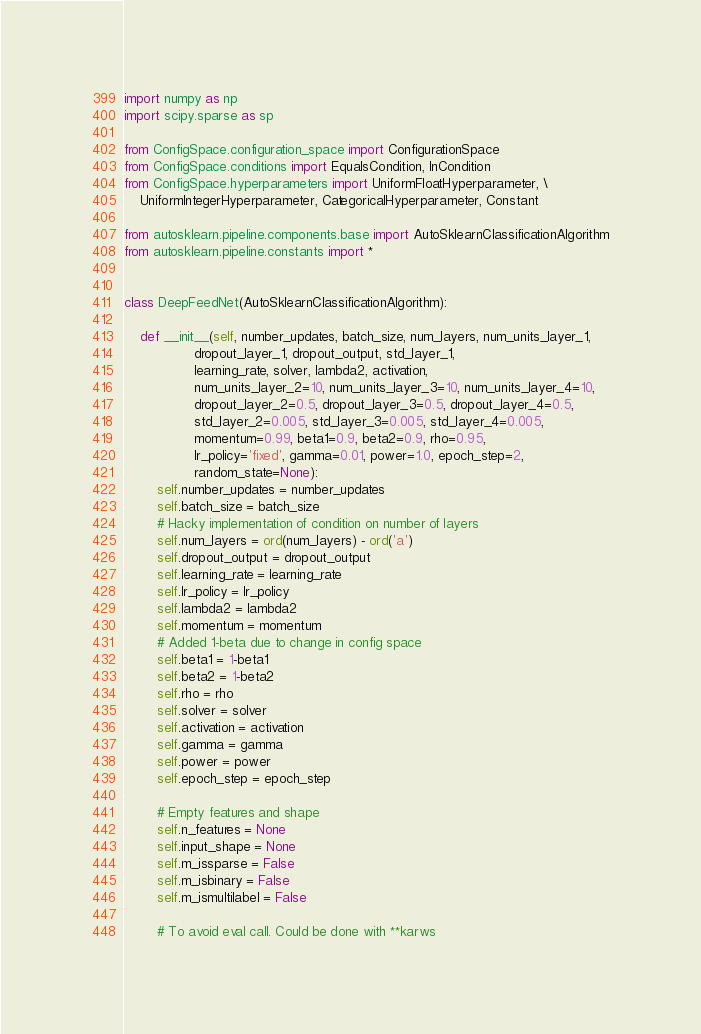<code> <loc_0><loc_0><loc_500><loc_500><_Python_>import numpy as np
import scipy.sparse as sp

from ConfigSpace.configuration_space import ConfigurationSpace
from ConfigSpace.conditions import EqualsCondition, InCondition
from ConfigSpace.hyperparameters import UniformFloatHyperparameter, \
    UniformIntegerHyperparameter, CategoricalHyperparameter, Constant

from autosklearn.pipeline.components.base import AutoSklearnClassificationAlgorithm
from autosklearn.pipeline.constants import *


class DeepFeedNet(AutoSklearnClassificationAlgorithm):

    def __init__(self, number_updates, batch_size, num_layers, num_units_layer_1,
                 dropout_layer_1, dropout_output, std_layer_1,
                 learning_rate, solver, lambda2, activation,
                 num_units_layer_2=10, num_units_layer_3=10, num_units_layer_4=10,
                 dropout_layer_2=0.5, dropout_layer_3=0.5, dropout_layer_4=0.5,
                 std_layer_2=0.005, std_layer_3=0.005, std_layer_4=0.005,
                 momentum=0.99, beta1=0.9, beta2=0.9, rho=0.95,
                 lr_policy='fixed', gamma=0.01, power=1.0, epoch_step=2,
                 random_state=None):
        self.number_updates = number_updates
        self.batch_size = batch_size
        # Hacky implementation of condition on number of layers
        self.num_layers = ord(num_layers) - ord('a')
        self.dropout_output = dropout_output
        self.learning_rate = learning_rate
        self.lr_policy = lr_policy
        self.lambda2 = lambda2
        self.momentum = momentum
        # Added 1-beta due to change in config space
        self.beta1 = 1-beta1
        self.beta2 = 1-beta2
        self.rho = rho
        self.solver = solver
        self.activation = activation
        self.gamma = gamma
        self.power = power
        self.epoch_step = epoch_step

        # Empty features and shape
        self.n_features = None
        self.input_shape = None
        self.m_issparse = False
        self.m_isbinary = False
        self.m_ismultilabel = False

        # To avoid eval call. Could be done with **karws</code> 